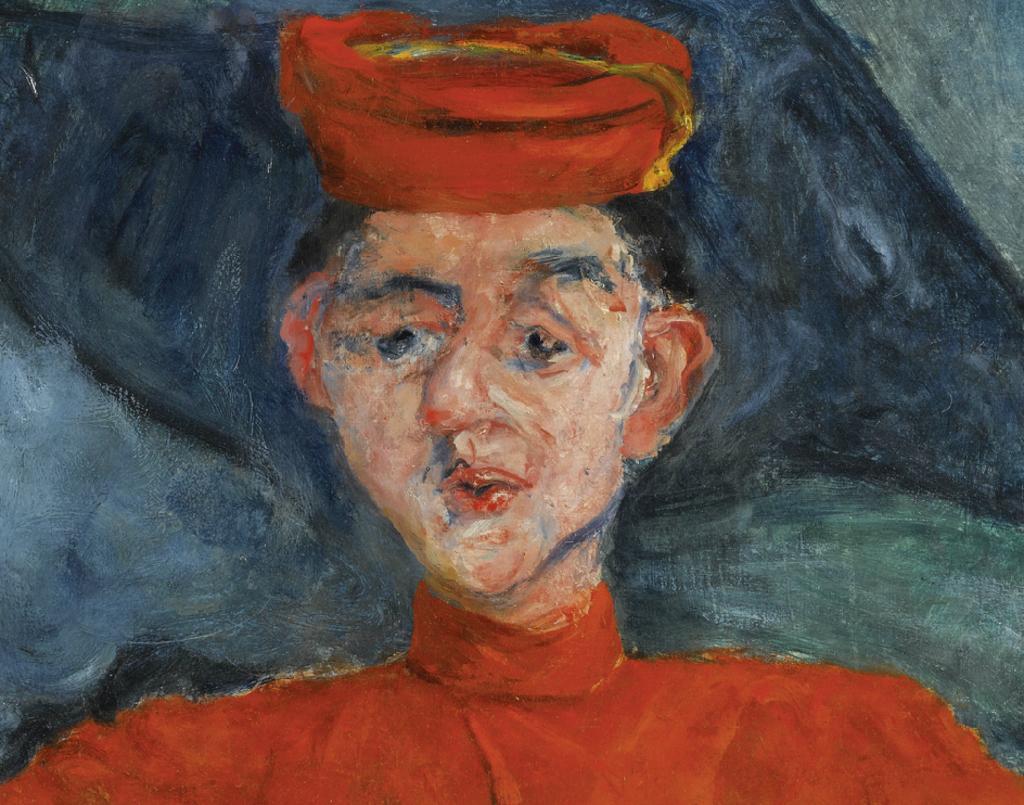In one or two sentences, can you explain what this image depicts? In the image we can see a painting of a person wearing clothes and a cap. 